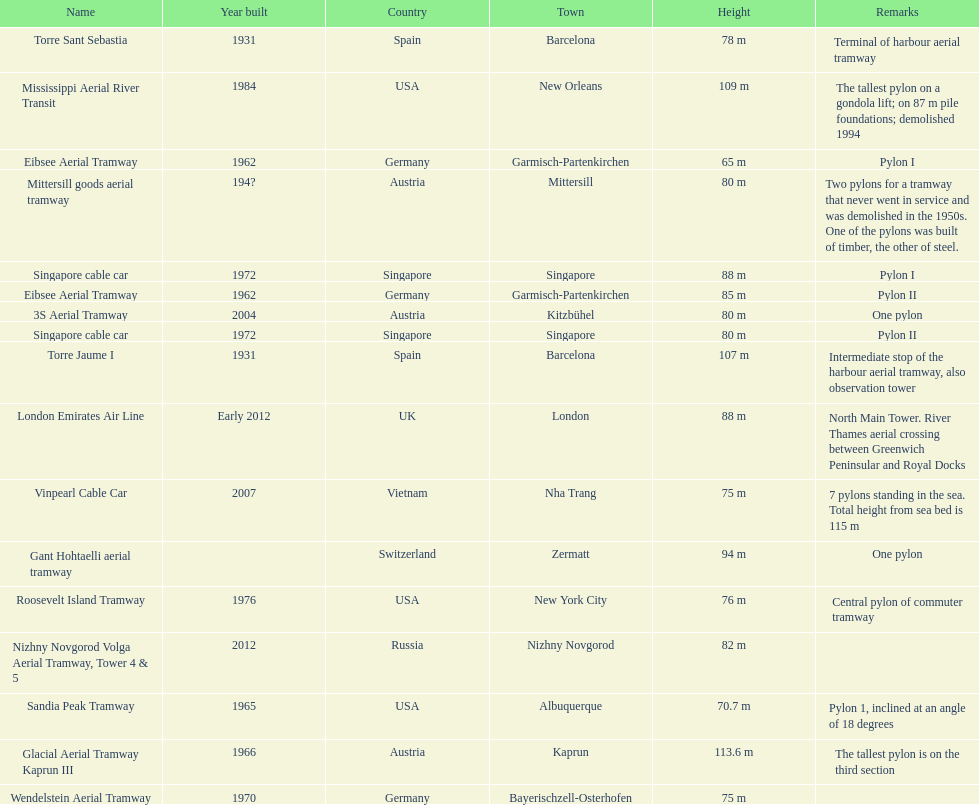What is the total number of pylons listed? 17. 